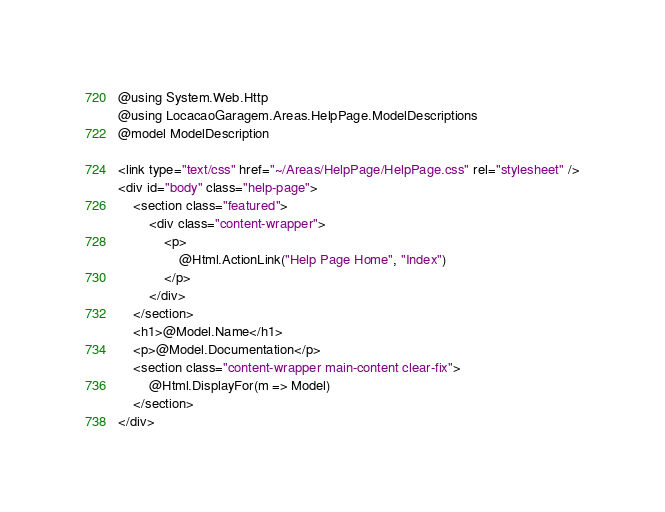<code> <loc_0><loc_0><loc_500><loc_500><_C#_>@using System.Web.Http
@using LocacaoGaragem.Areas.HelpPage.ModelDescriptions
@model ModelDescription

<link type="text/css" href="~/Areas/HelpPage/HelpPage.css" rel="stylesheet" />
<div id="body" class="help-page">
    <section class="featured">
        <div class="content-wrapper">
            <p>
                @Html.ActionLink("Help Page Home", "Index")
            </p>
        </div>
    </section>
    <h1>@Model.Name</h1>
    <p>@Model.Documentation</p>
    <section class="content-wrapper main-content clear-fix">
        @Html.DisplayFor(m => Model)
    </section>
</div>
</code> 